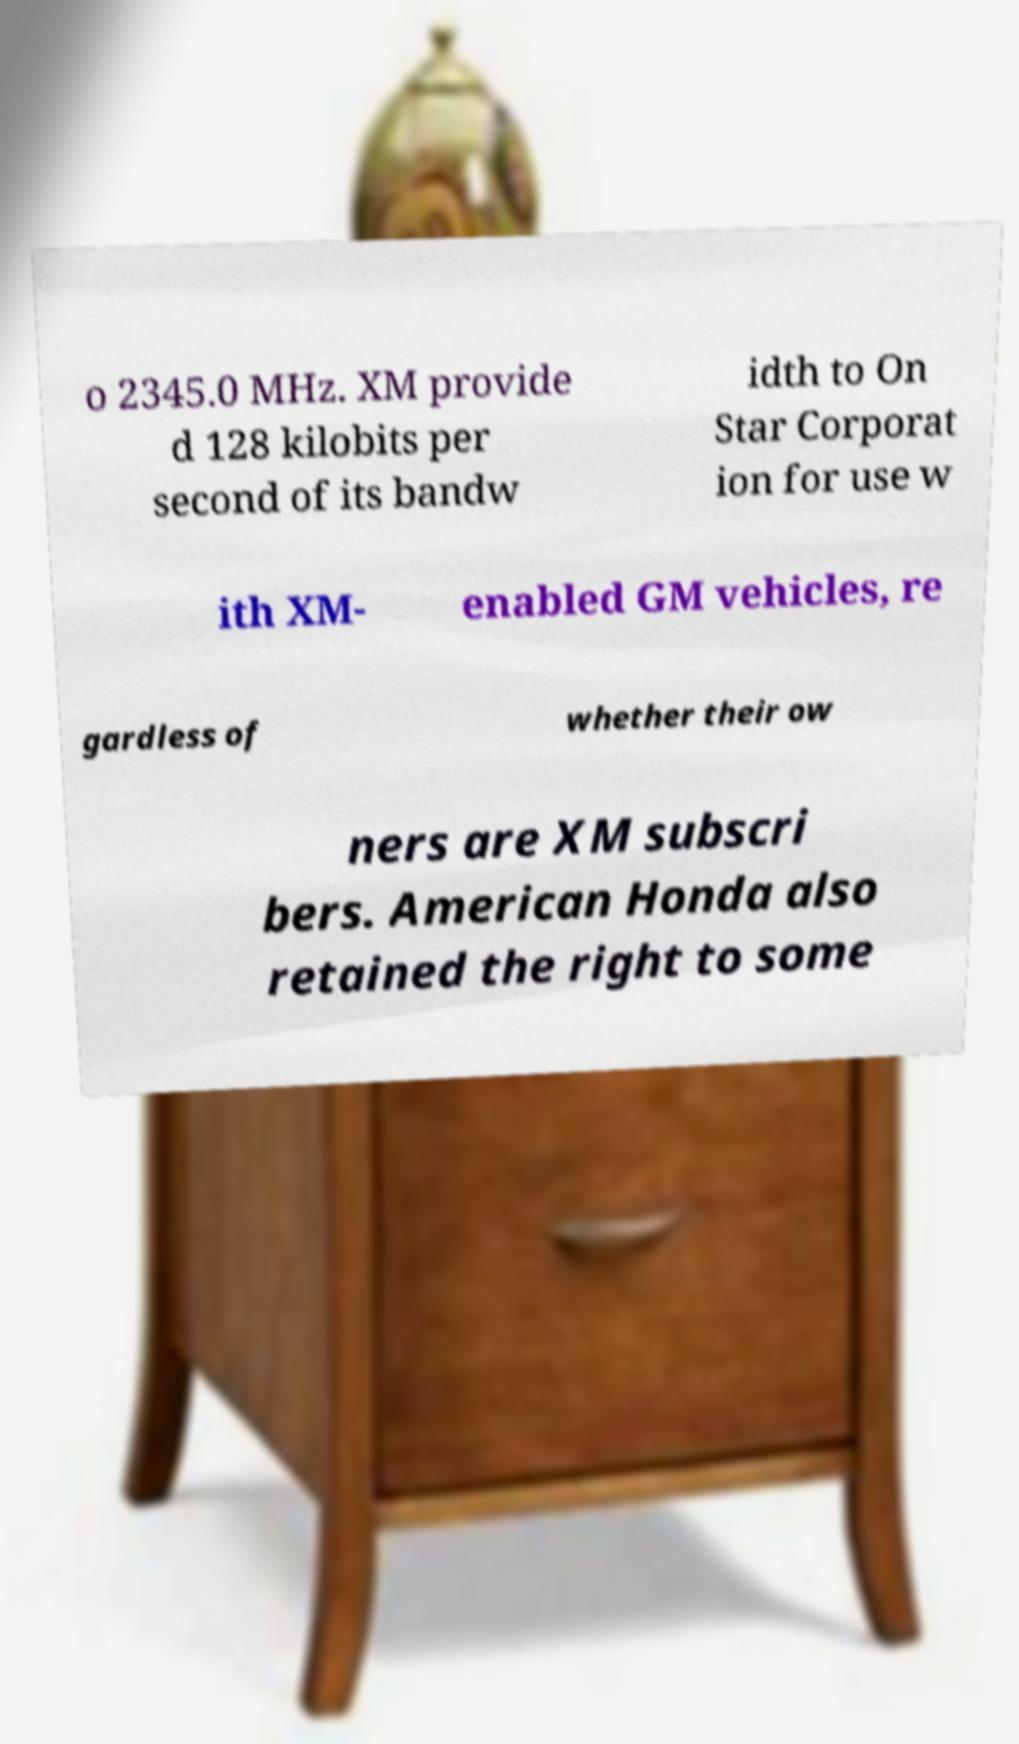Please read and relay the text visible in this image. What does it say? o 2345.0 MHz. XM provide d 128 kilobits per second of its bandw idth to On Star Corporat ion for use w ith XM- enabled GM vehicles, re gardless of whether their ow ners are XM subscri bers. American Honda also retained the right to some 